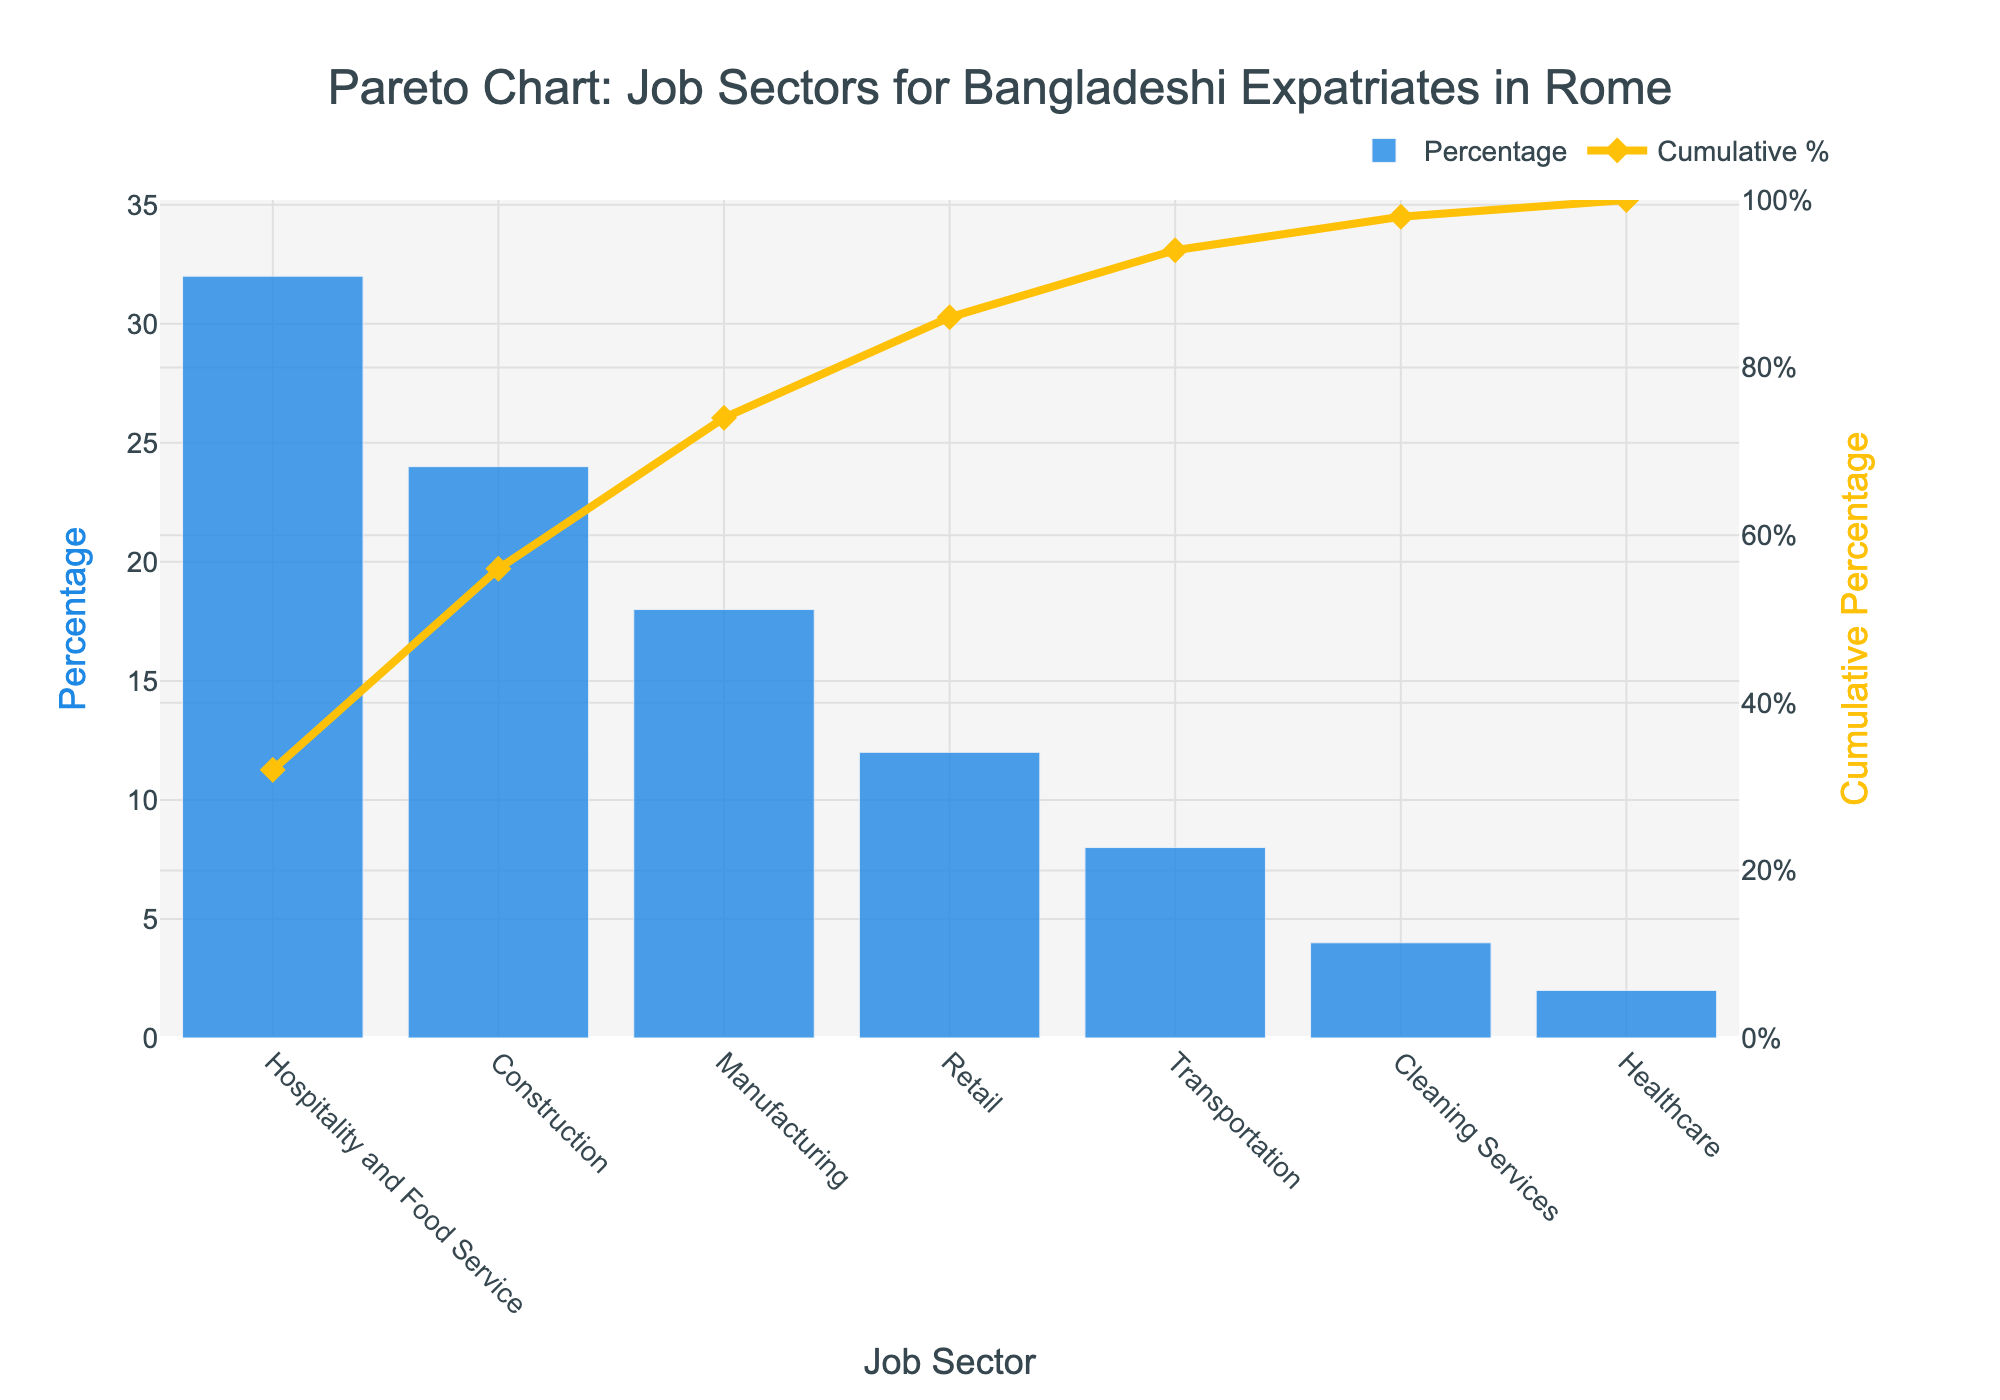What is the title of the chart? The title is located at the top of the chart and provides an overview of what the chart represents. By reading it, one can easily identify the main focus of the visual.
Answer: Pareto Chart: Job Sectors for Bangladeshi Expatriates in Rome Which job sector has the highest percentage of employment? The bar with the greatest height among the presented categories indicates the sector with the highest percentage of employment.
Answer: Hospitality and Food Service What is the cumulative percentage after the top three job sectors? Adding the cumulative percentages at the top of the line chart for the first three categories (Hospitality and Food Service, Construction, Manufacturing). By observing the points where the line intersects, the sum can be determined.
Answer: 74% Which job sector employs more people, Manufacturing or Retail? By comparing the heights of the bars for Manufacturing and Retail, one can see which sector has a higher percentage.
Answer: Manufacturing What percentage of Bangladeshi expatriates in Rome work in Transportation? The height of the bar labeled Transportation directly gives the percentage of people employed in that sector.
Answer: 8% What is the combined percentage of employment for Healthcare and Cleaning Services? This requires summing up the percentages of Healthcare and Cleaning Services by adding them together.
Answer: 6% What percentage of employment does the construction sector contribute to? The height of the bar labeled Construction gives the information needed for this question.
Answer: 24% What's the total percentage of employment covered by the top two job sectors? Adding the percentages of the top two sectors according to the chart: Hospitality and Food Service (32%) and Construction (24%).
Answer: 56% Which sector's bar color represents the highest percentage of employment? Here, you need to identify which bar has the specified color (#1E88E5) and the highest percentage.
Answer: Hospitality and Food Service What is the cumulative percentage after the bottom three job sectors? Add the percentages of the bottom three sectors (Transportation, Cleaning Services, Healthcare), referring to the cumulative line plot to cross-check.
Answer: 86% 